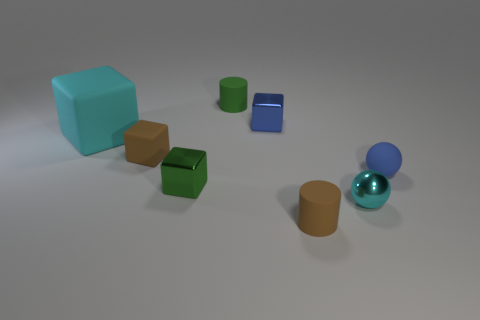The big matte thing that is the same color as the shiny sphere is what shape?
Give a very brief answer. Cube. Does the rubber object in front of the tiny cyan metal thing have the same color as the small matte object that is to the left of the green cylinder?
Ensure brevity in your answer.  Yes. There is a cyan object that is made of the same material as the small brown cube; what is its shape?
Offer a very short reply. Cube. What number of rubber objects are both to the right of the cyan rubber cube and behind the blue rubber object?
Keep it short and to the point. 2. Are there any other things that are the same shape as the green metallic object?
Ensure brevity in your answer.  Yes. There is a green thing in front of the big cyan thing; what size is it?
Provide a succinct answer. Small. What number of other objects are the same color as the small rubber block?
Your answer should be compact. 1. The cyan thing that is to the right of the small shiny block that is behind the brown cube is made of what material?
Provide a succinct answer. Metal. There is a matte cylinder that is on the left side of the small blue block; is it the same color as the small rubber ball?
Your response must be concise. No. Is there anything else that has the same material as the tiny green cylinder?
Your answer should be very brief. Yes. 